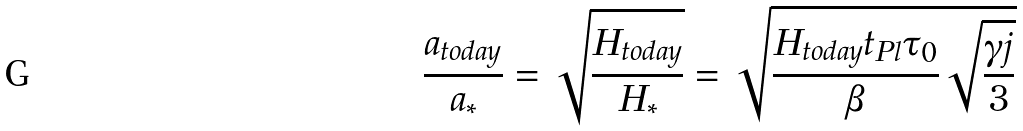<formula> <loc_0><loc_0><loc_500><loc_500>\frac { a _ { \text {today} } } { a _ { * } } = \sqrt { \frac { H _ { t o d a y } } { H _ { * } } } = \sqrt { \frac { H _ { t o d a y } t _ { \text {Pl} } \tau _ { 0 } } { \beta } \sqrt { \frac { \gamma j } { 3 } } }</formula> 